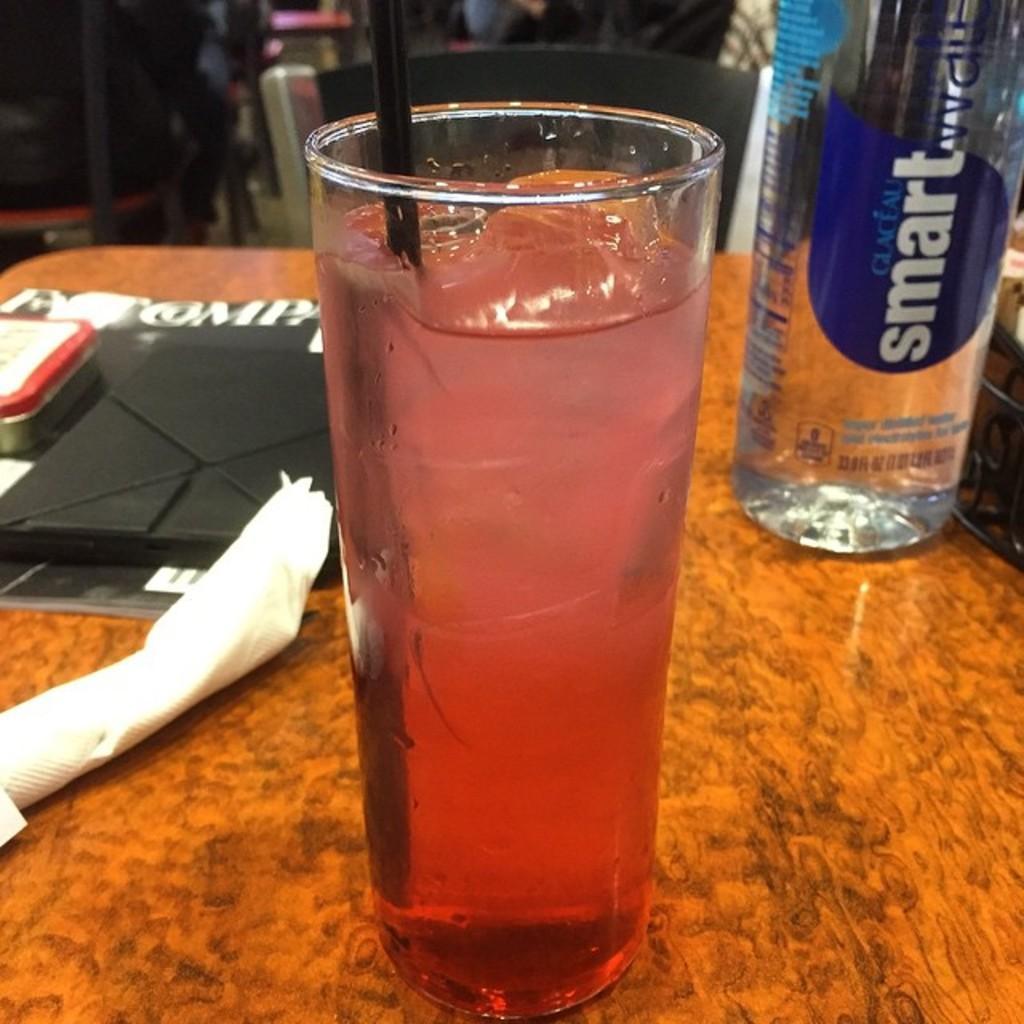Please provide a concise description of this image. In this image I can see a glass with some liquid in it. On the right side there is a water bottle on the table. 